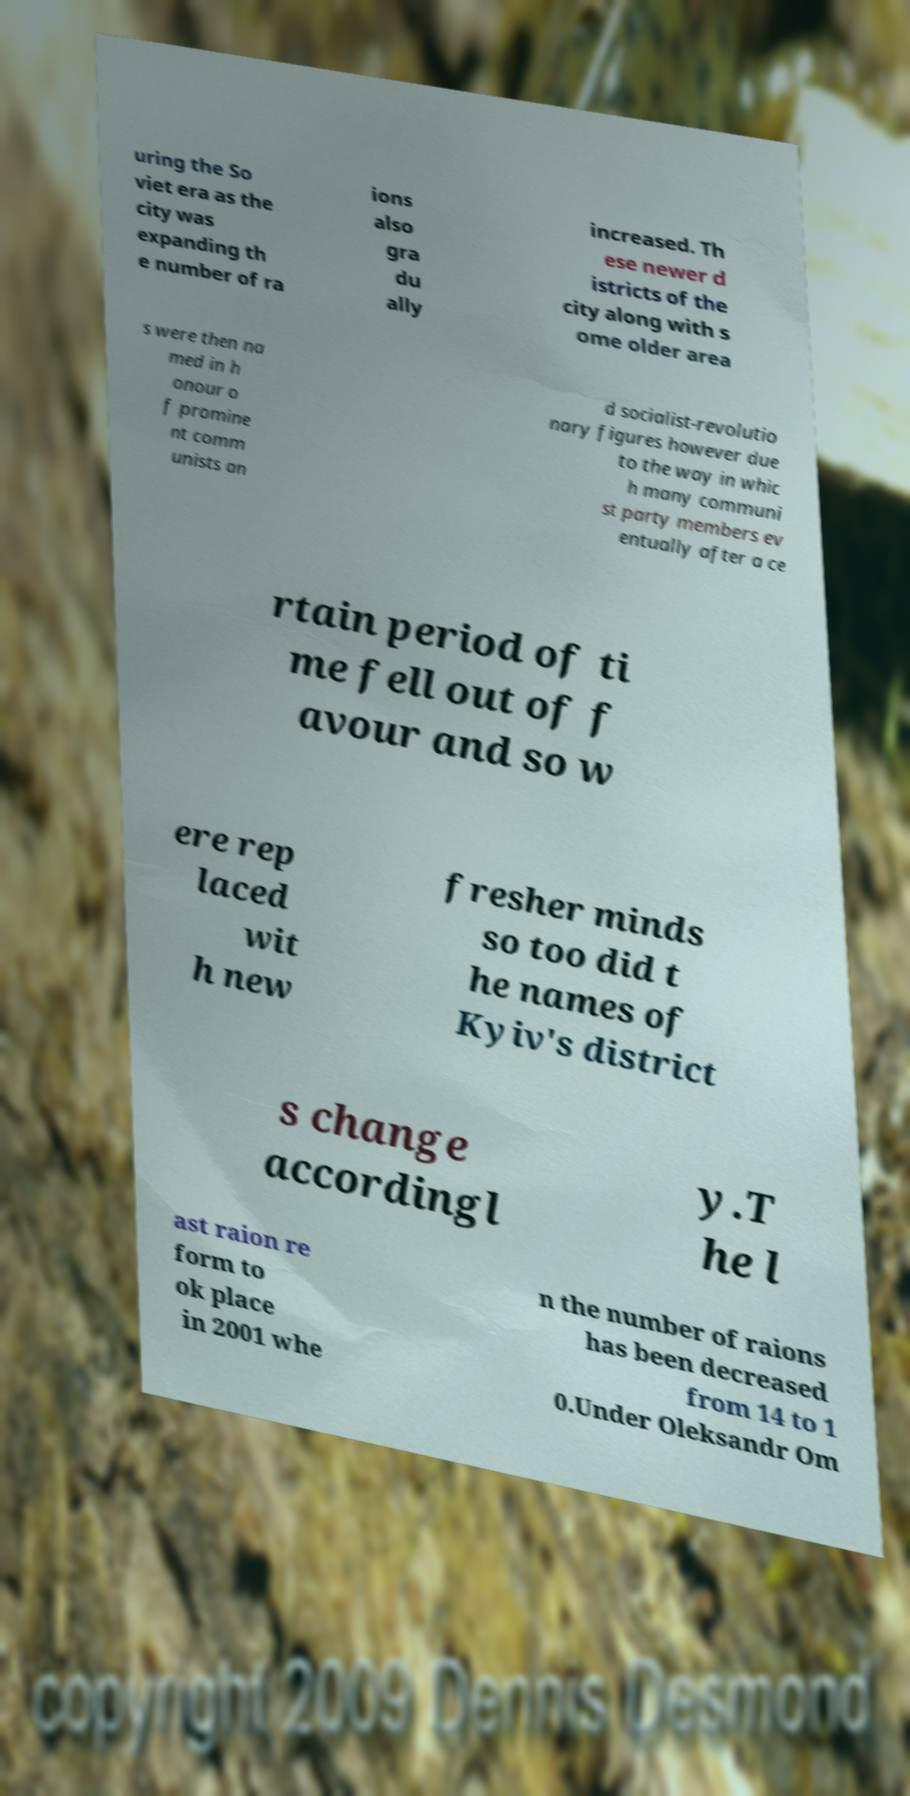Please identify and transcribe the text found in this image. uring the So viet era as the city was expanding th e number of ra ions also gra du ally increased. Th ese newer d istricts of the city along with s ome older area s were then na med in h onour o f promine nt comm unists an d socialist-revolutio nary figures however due to the way in whic h many communi st party members ev entually after a ce rtain period of ti me fell out of f avour and so w ere rep laced wit h new fresher minds so too did t he names of Kyiv's district s change accordingl y.T he l ast raion re form to ok place in 2001 whe n the number of raions has been decreased from 14 to 1 0.Under Oleksandr Om 